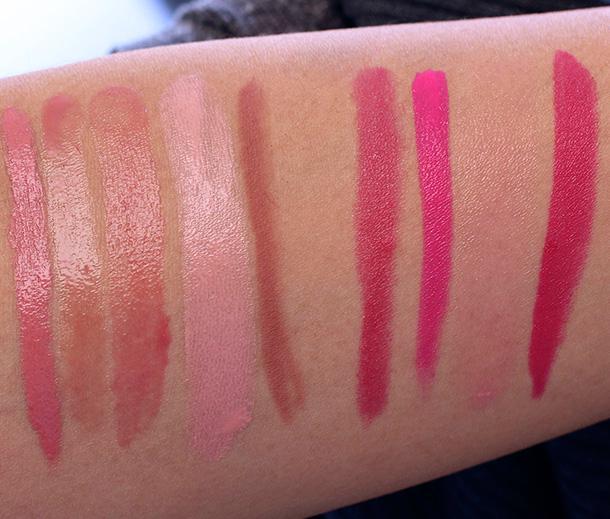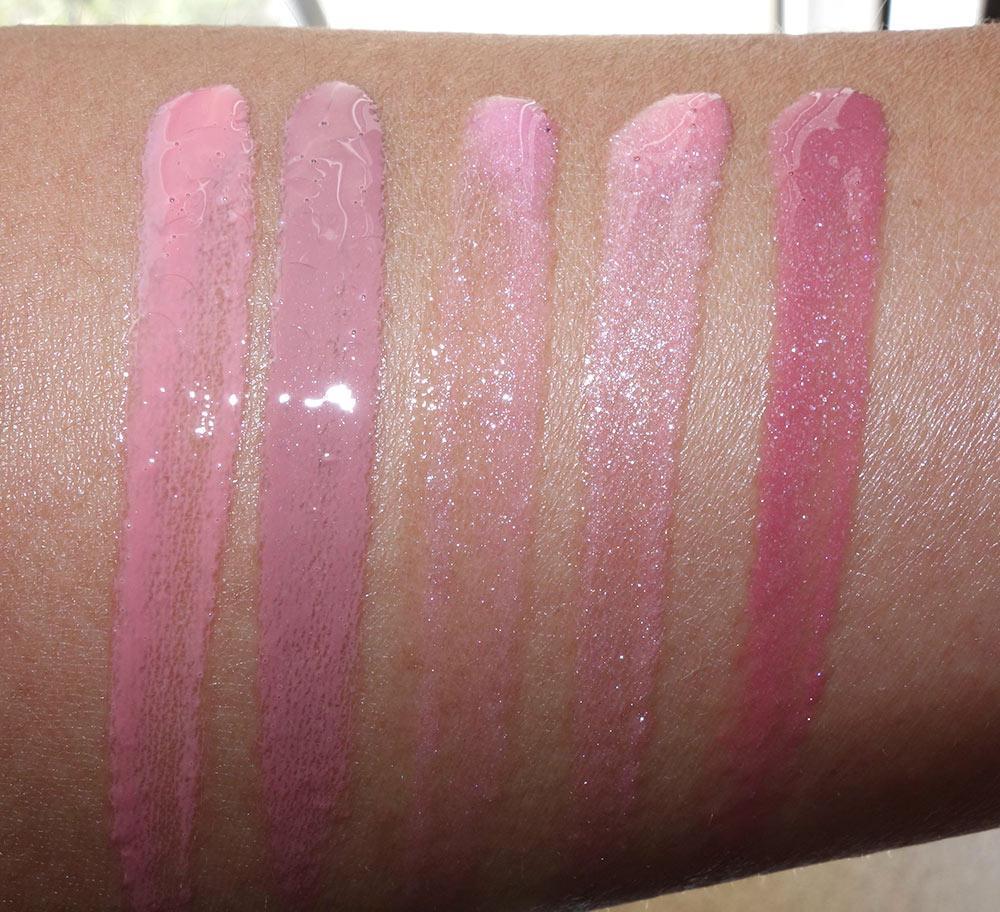The first image is the image on the left, the second image is the image on the right. Considering the images on both sides, is "The person on the left is lighter skinned than the person on the right." valid? Answer yes or no. Yes. The first image is the image on the left, the second image is the image on the right. Assess this claim about the two images: "There are at least 13 stripes of different lipstick colors on the arms.". Correct or not? Answer yes or no. Yes. 